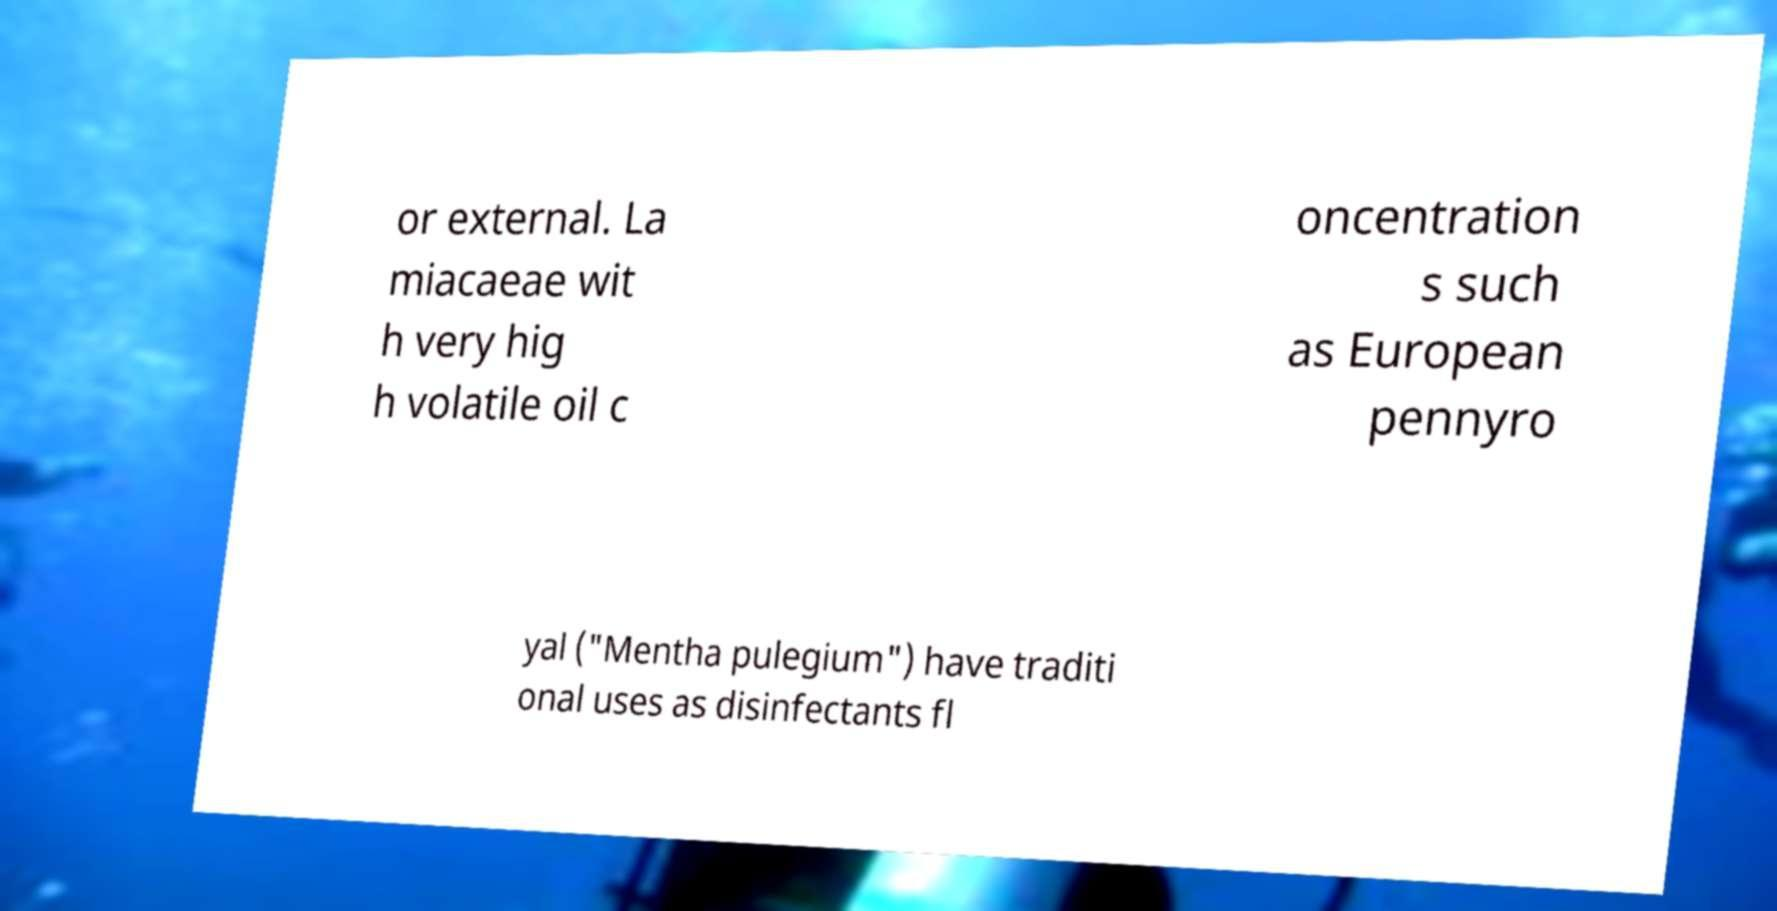Could you extract and type out the text from this image? or external. La miacaeae wit h very hig h volatile oil c oncentration s such as European pennyro yal ("Mentha pulegium") have traditi onal uses as disinfectants fl 